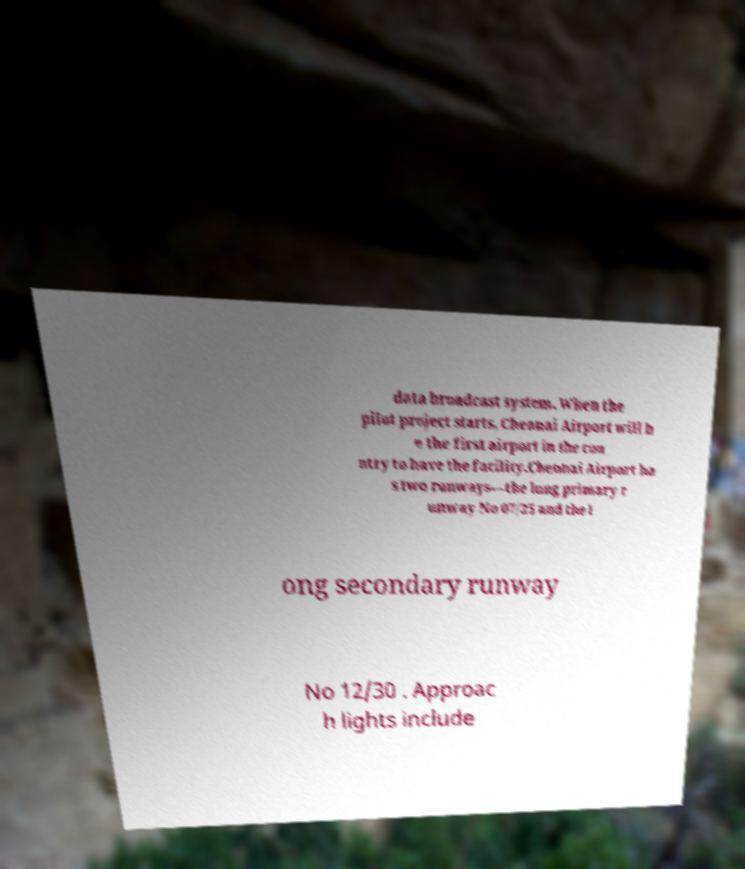What messages or text are displayed in this image? I need them in a readable, typed format. data broadcast system. When the pilot project starts, Chennai Airport will b e the first airport in the cou ntry to have the facility.Chennai Airport ha s two runways—the long primary r unway No 07/25 and the l ong secondary runway No 12/30 . Approac h lights include 